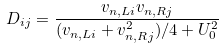Convert formula to latex. <formula><loc_0><loc_0><loc_500><loc_500>D _ { i j } = \frac { v _ { n , L i } v _ { n , R j } } { ( v _ { n , L i } + v _ { n , R j } ^ { 2 } ) / 4 + U _ { 0 } ^ { 2 } }</formula> 